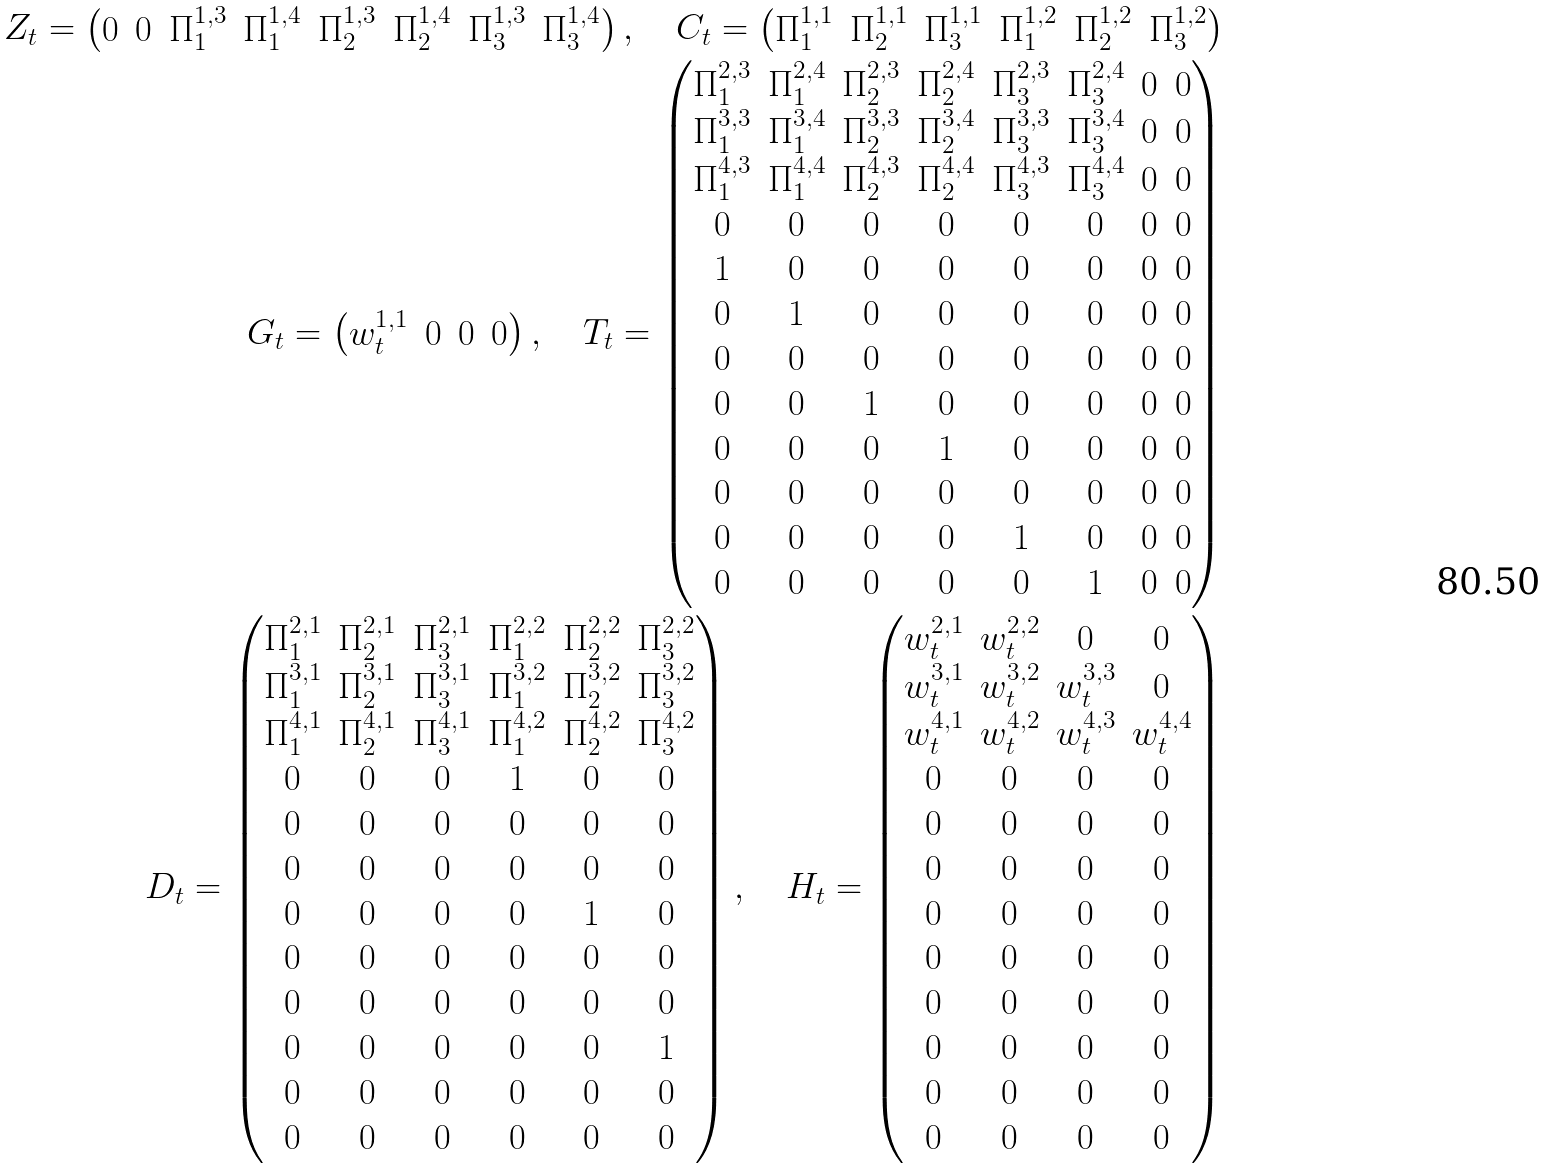<formula> <loc_0><loc_0><loc_500><loc_500>Z _ { t } = \begin{pmatrix} 0 & 0 & \Pi _ { 1 } ^ { 1 , 3 } & \Pi _ { 1 } ^ { 1 , 4 } & \Pi _ { 2 } ^ { 1 , 3 } & \Pi _ { 2 } ^ { 1 , 4 } & \Pi _ { 3 } ^ { 1 , 3 } & \Pi _ { 3 } ^ { 1 , 4 } \end{pmatrix} , \quad C _ { t } = \begin{pmatrix} \Pi _ { 1 } ^ { 1 , 1 } & \Pi _ { 2 } ^ { 1 , 1 } & \Pi _ { 3 } ^ { 1 , 1 } & \Pi _ { 1 } ^ { 1 , 2 } & \Pi _ { 2 } ^ { 1 , 2 } & \Pi _ { 3 } ^ { 1 , 2 } \end{pmatrix} \\ G _ { t } = \begin{pmatrix} w _ { t } ^ { 1 , 1 } & 0 & 0 & 0 \end{pmatrix} , \quad T _ { t } = \begin{pmatrix} \Pi _ { 1 } ^ { 2 , 3 } & \Pi _ { 1 } ^ { 2 , 4 } & \Pi _ { 2 } ^ { 2 , 3 } & \Pi _ { 2 } ^ { 2 , 4 } & \Pi _ { 3 } ^ { 2 , 3 } & \Pi _ { 3 } ^ { 2 , 4 } & 0 & 0 \\ \Pi _ { 1 } ^ { 3 , 3 } & \Pi _ { 1 } ^ { 3 , 4 } & \Pi _ { 2 } ^ { 3 , 3 } & \Pi _ { 2 } ^ { 3 , 4 } & \Pi _ { 3 } ^ { 3 , 3 } & \Pi _ { 3 } ^ { 3 , 4 } & 0 & 0 \\ \Pi _ { 1 } ^ { 4 , 3 } & \Pi _ { 1 } ^ { 4 , 4 } & \Pi _ { 2 } ^ { 4 , 3 } & \Pi _ { 2 } ^ { 4 , 4 } & \Pi _ { 3 } ^ { 4 , 3 } & \Pi _ { 3 } ^ { 4 , 4 } & 0 & 0 \\ 0 & 0 & 0 & 0 & 0 & 0 & 0 & 0 \\ 1 & 0 & 0 & 0 & 0 & 0 & 0 & 0 \\ 0 & 1 & 0 & 0 & 0 & 0 & 0 & 0 \\ 0 & 0 & 0 & 0 & 0 & 0 & 0 & 0 \\ 0 & 0 & 1 & 0 & 0 & 0 & 0 & 0 \\ 0 & 0 & 0 & 1 & 0 & 0 & 0 & 0 \\ 0 & 0 & 0 & 0 & 0 & 0 & 0 & 0 \\ 0 & 0 & 0 & 0 & 1 & 0 & 0 & 0 \\ 0 & 0 & 0 & 0 & 0 & 1 & 0 & 0 \\ \end{pmatrix} \\ D _ { t } = \begin{pmatrix} \Pi _ { 1 } ^ { 2 , 1 } & \Pi _ { 2 } ^ { 2 , 1 } & \Pi _ { 3 } ^ { 2 , 1 } & \Pi _ { 1 } ^ { 2 , 2 } & \Pi _ { 2 } ^ { 2 , 2 } & \Pi _ { 3 } ^ { 2 , 2 } \\ \Pi _ { 1 } ^ { 3 , 1 } & \Pi _ { 2 } ^ { 3 , 1 } & \Pi _ { 3 } ^ { 3 , 1 } & \Pi _ { 1 } ^ { 3 , 2 } & \Pi _ { 2 } ^ { 3 , 2 } & \Pi _ { 3 } ^ { 3 , 2 } \\ \Pi _ { 1 } ^ { 4 , 1 } & \Pi _ { 2 } ^ { 4 , 1 } & \Pi _ { 3 } ^ { 4 , 1 } & \Pi _ { 1 } ^ { 4 , 2 } & \Pi _ { 2 } ^ { 4 , 2 } & \Pi _ { 3 } ^ { 4 , 2 } \\ 0 & 0 & 0 & 1 & 0 & 0 \\ 0 & 0 & 0 & 0 & 0 & 0 \\ 0 & 0 & 0 & 0 & 0 & 0 \\ 0 & 0 & 0 & 0 & 1 & 0 \\ 0 & 0 & 0 & 0 & 0 & 0 \\ 0 & 0 & 0 & 0 & 0 & 0 \\ 0 & 0 & 0 & 0 & 0 & 1 \\ 0 & 0 & 0 & 0 & 0 & 0 \\ 0 & 0 & 0 & 0 & 0 & 0 \end{pmatrix} , \quad H _ { t } = \begin{pmatrix} w _ { t } ^ { 2 , 1 } & w _ { t } ^ { 2 , 2 } & 0 & 0 \\ w _ { t } ^ { 3 , 1 } & w _ { t } ^ { 3 , 2 } & w _ { t } ^ { 3 , 3 } & 0 \\ w _ { t } ^ { 4 , 1 } & w _ { t } ^ { 4 , 2 } & w _ { t } ^ { 4 , 3 } & w _ { t } ^ { 4 , 4 } \\ 0 & 0 & 0 & 0 \\ 0 & 0 & 0 & 0 \\ 0 & 0 & 0 & 0 \\ 0 & 0 & 0 & 0 \\ 0 & 0 & 0 & 0 \\ 0 & 0 & 0 & 0 \\ 0 & 0 & 0 & 0 \\ 0 & 0 & 0 & 0 \\ 0 & 0 & 0 & 0 \end{pmatrix}</formula> 